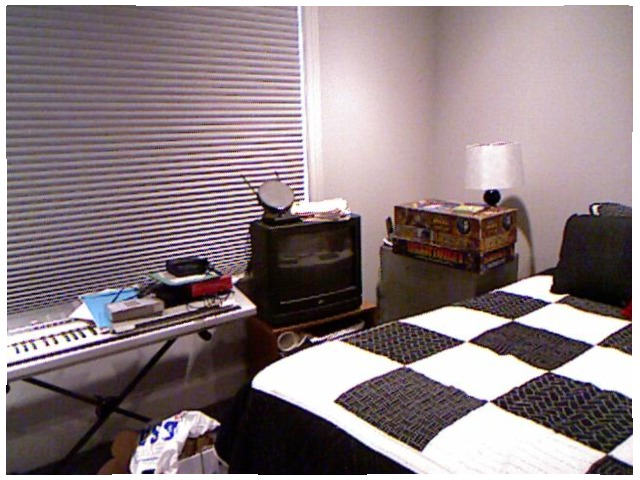<image>
Is there a pillow under the comforter? No. The pillow is not positioned under the comforter. The vertical relationship between these objects is different. Where is the clock in relation to the keyboard? Is it on the keyboard? Yes. Looking at the image, I can see the clock is positioned on top of the keyboard, with the keyboard providing support. Is the blanket in the tv? No. The blanket is not contained within the tv. These objects have a different spatial relationship. 